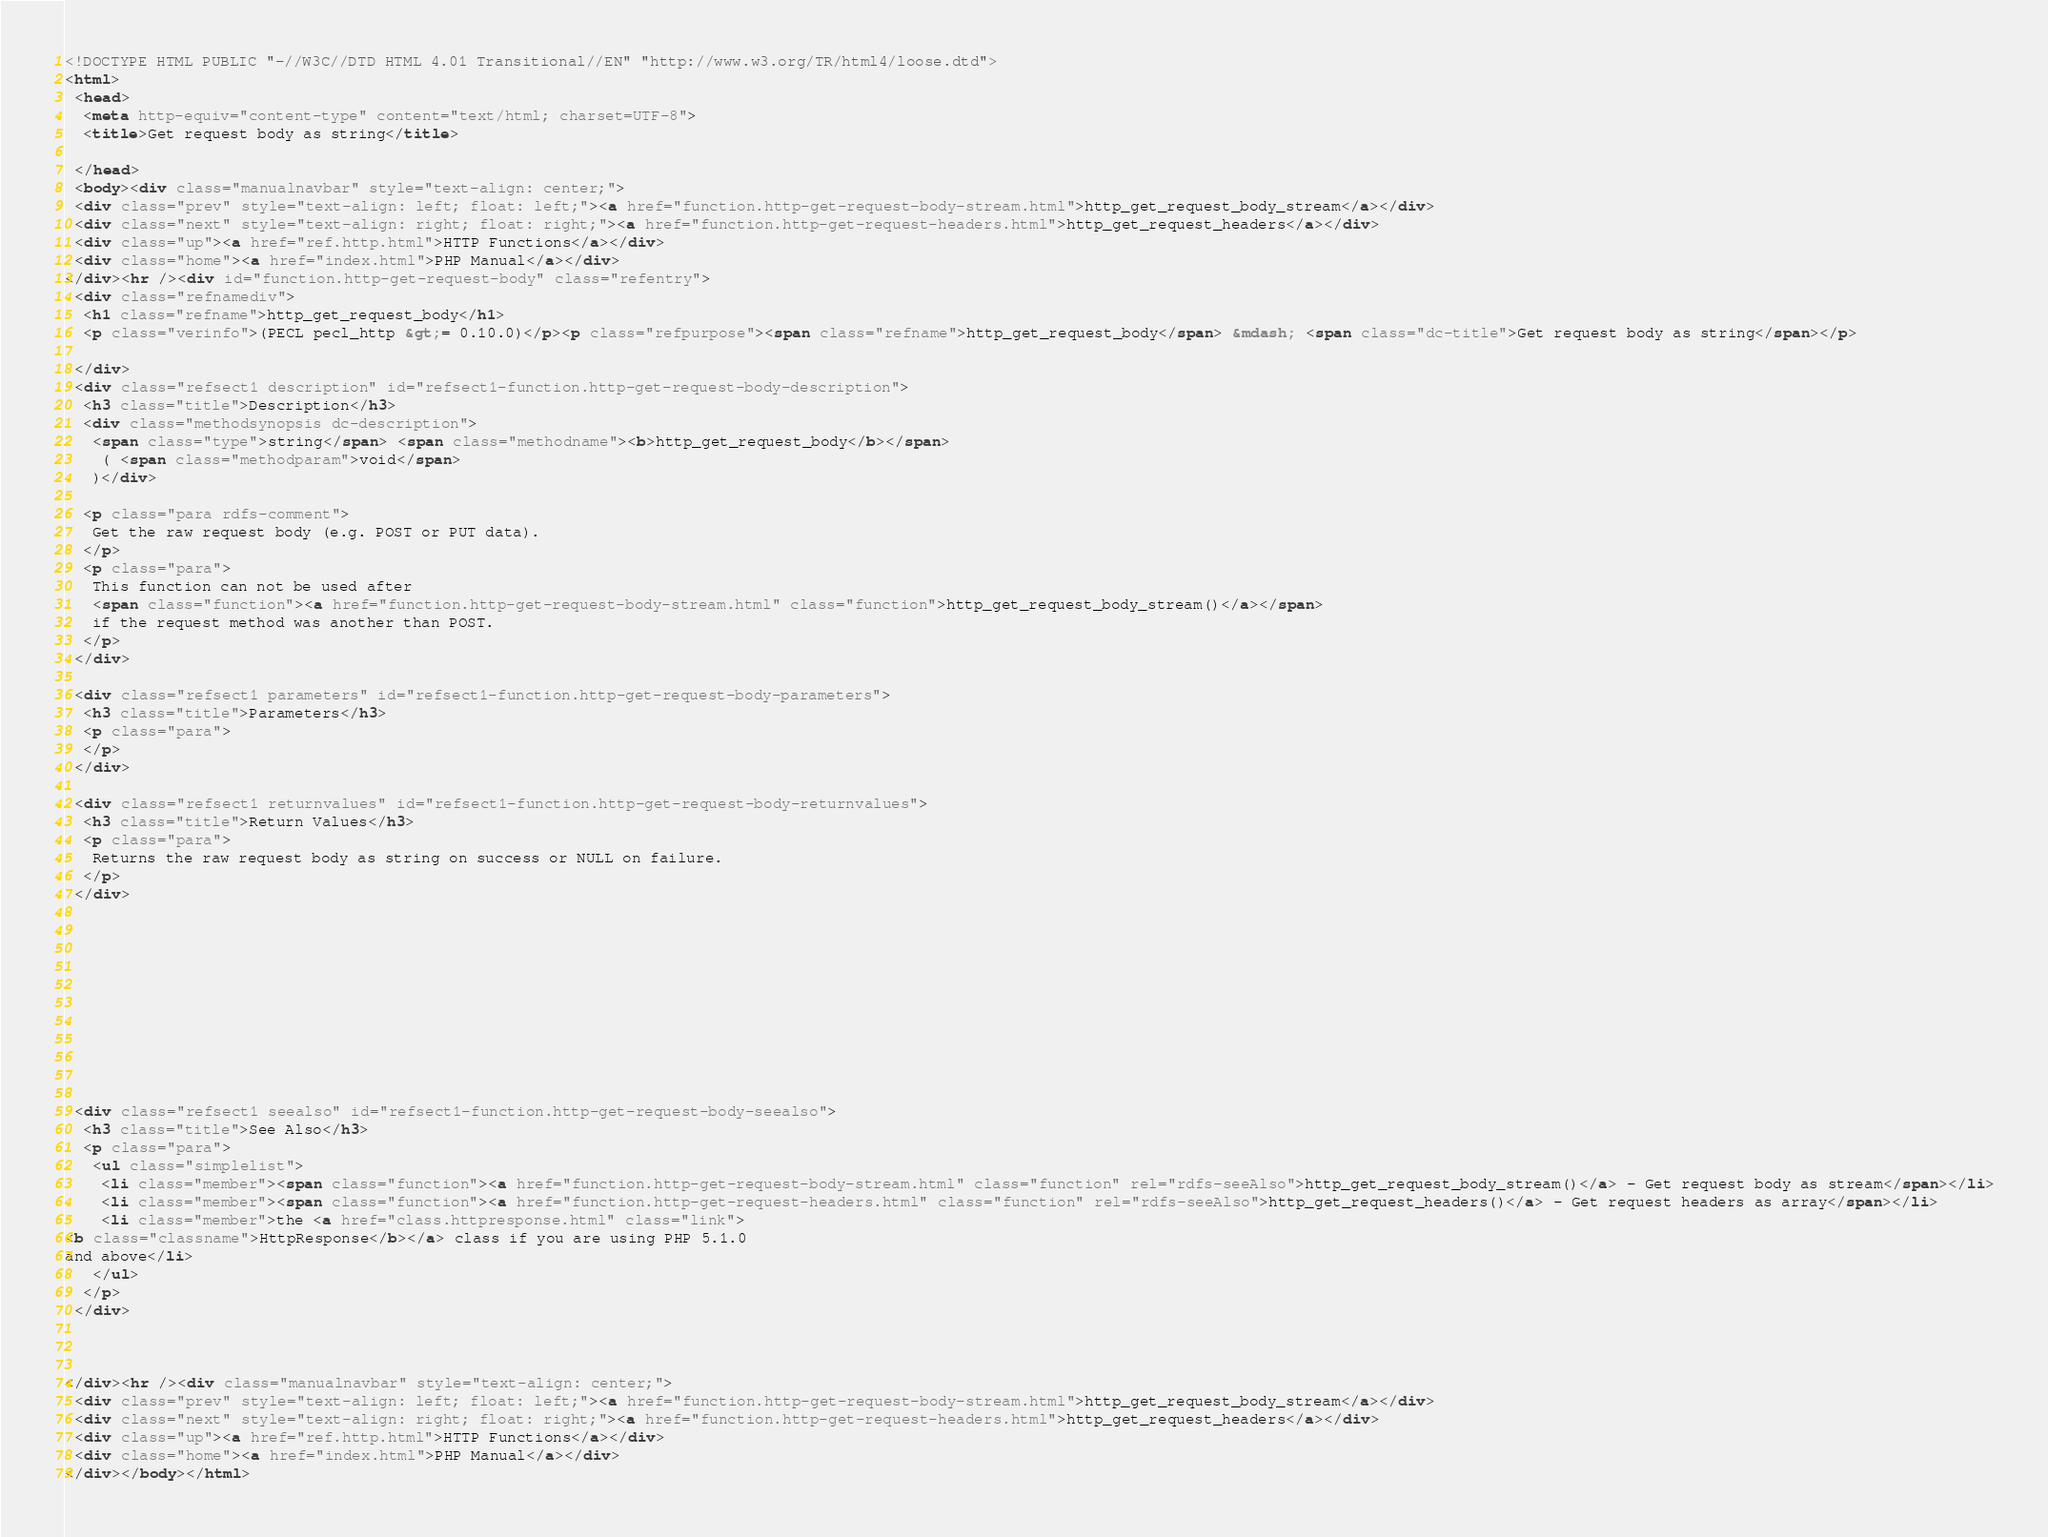Convert code to text. <code><loc_0><loc_0><loc_500><loc_500><_HTML_><!DOCTYPE HTML PUBLIC "-//W3C//DTD HTML 4.01 Transitional//EN" "http://www.w3.org/TR/html4/loose.dtd">
<html>
 <head>
  <meta http-equiv="content-type" content="text/html; charset=UTF-8">
  <title>Get request body as string</title>

 </head>
 <body><div class="manualnavbar" style="text-align: center;">
 <div class="prev" style="text-align: left; float: left;"><a href="function.http-get-request-body-stream.html">http_get_request_body_stream</a></div>
 <div class="next" style="text-align: right; float: right;"><a href="function.http-get-request-headers.html">http_get_request_headers</a></div>
 <div class="up"><a href="ref.http.html">HTTP Functions</a></div>
 <div class="home"><a href="index.html">PHP Manual</a></div>
</div><hr /><div id="function.http-get-request-body" class="refentry">
 <div class="refnamediv">
  <h1 class="refname">http_get_request_body</h1>
  <p class="verinfo">(PECL pecl_http &gt;= 0.10.0)</p><p class="refpurpose"><span class="refname">http_get_request_body</span> &mdash; <span class="dc-title">Get request body as string</span></p>

 </div>
 <div class="refsect1 description" id="refsect1-function.http-get-request-body-description">
  <h3 class="title">Description</h3>
  <div class="methodsynopsis dc-description">
   <span class="type">string</span> <span class="methodname"><b>http_get_request_body</b></span>
    ( <span class="methodparam">void</span>
   )</div>

  <p class="para rdfs-comment">
   Get the raw request body (e.g. POST or PUT data).
  </p>
  <p class="para">
   This function can not be used after 
   <span class="function"><a href="function.http-get-request-body-stream.html" class="function">http_get_request_body_stream()</a></span>
   if the request method was another than POST.
  </p>
 </div>

 <div class="refsect1 parameters" id="refsect1-function.http-get-request-body-parameters">
  <h3 class="title">Parameters</h3>
  <p class="para">
  </p>
 </div>

 <div class="refsect1 returnvalues" id="refsect1-function.http-get-request-body-returnvalues">
  <h3 class="title">Return Values</h3>
  <p class="para">
   Returns the raw request body as string on success or NULL on failure.
  </p>
 </div>


 


 


 


 <div class="refsect1 seealso" id="refsect1-function.http-get-request-body-seealso">
  <h3 class="title">See Also</h3>
  <p class="para">
   <ul class="simplelist">
    <li class="member"><span class="function"><a href="function.http-get-request-body-stream.html" class="function" rel="rdfs-seeAlso">http_get_request_body_stream()</a> - Get request body as stream</span></li>
    <li class="member"><span class="function"><a href="function.http-get-request-headers.html" class="function" rel="rdfs-seeAlso">http_get_request_headers()</a> - Get request headers as array</span></li>
    <li class="member">the <a href="class.httpresponse.html" class="link">
<b class="classname">HttpResponse</b></a> class if you are using PHP 5.1.0
and above</li>
   </ul>
  </p>
 </div>



</div><hr /><div class="manualnavbar" style="text-align: center;">
 <div class="prev" style="text-align: left; float: left;"><a href="function.http-get-request-body-stream.html">http_get_request_body_stream</a></div>
 <div class="next" style="text-align: right; float: right;"><a href="function.http-get-request-headers.html">http_get_request_headers</a></div>
 <div class="up"><a href="ref.http.html">HTTP Functions</a></div>
 <div class="home"><a href="index.html">PHP Manual</a></div>
</div></body></html>
</code> 